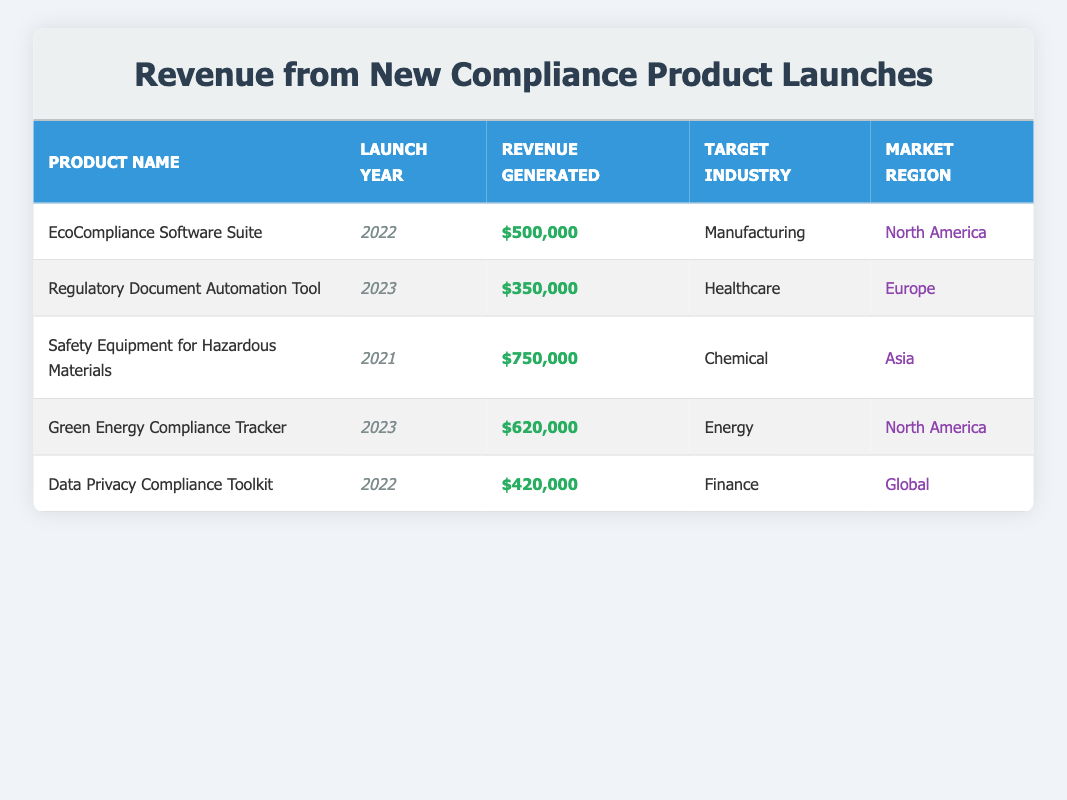What is the total revenue generated from all new product launches? To find the total revenue, we can sum the revenue generated for each product: 500000 (EcoCompliance Software Suite) + 350000 (Regulatory Document Automation Tool) + 750000 (Safety Equipment for Hazardous Materials) + 620000 (Green Energy Compliance Tracker) + 420000 (Data Privacy Compliance Toolkit) = 3140000.
Answer: 3140000 Which product generated the highest revenue and what was that revenue? By examining the revenue column, the Safety Equipment for Hazardous Materials shows the highest revenue of 750000.
Answer: Safety Equipment for Hazardous Materials, 750000 How many products were launched in the year 2023? In the table, I count two products launched in 2023: Regulatory Document Automation Tool and Green Energy Compliance Tracker.
Answer: 2 Did the EcoCompliance Software Suite generate more revenue than the Data Privacy Compliance Toolkit? Upon comparing their revenues, the EcoCompliance Software Suite generated 500000, and the Data Privacy Compliance Toolkit generated 420000, therefore, 500000 is more than 420000.
Answer: Yes What is the average revenue generated from products launched in 2022? The products launched in 2022 are the EcoCompliance Software Suite (500000) and Data Privacy Compliance Toolkit (420000). We calculate the average as follows: (500000 + 420000) / 2 = 460000.
Answer: 460000 Is there any product targeting the Finance industry that was launched in 2021? Checking the table, there is no mention of any product launched in 2021 targeting the Finance industry. The product launched in that year (Safety Equipment for Hazardous Materials) targets the Chemical industry.
Answer: No How much revenue was generated by products in North America? Analyzing the table, the products in North America are the EcoCompliance Software Suite (500000) and Green Energy Compliance Tracker (620000). We sum their revenues: 500000 + 620000 = 1120000.
Answer: 1120000 What was the revenue difference between the Regulatory Document Automation Tool and the Green Energy Compliance Tracker? The revenue for the Regulatory Document Automation Tool is 350000, and for the Green Energy Compliance Tracker, it is 620000. The difference is calculated as 620000 - 350000 = 270000.
Answer: 270000 Which market region had the lowest total revenue from new product launches? To determine the market region with the lowest total revenue, I will sum the revenue for each region: North America (500000 + 620000 = 1120000), Europe (350000), Asia (750000), and Global (420000). The lowest is Europe with 350000.
Answer: Europe 